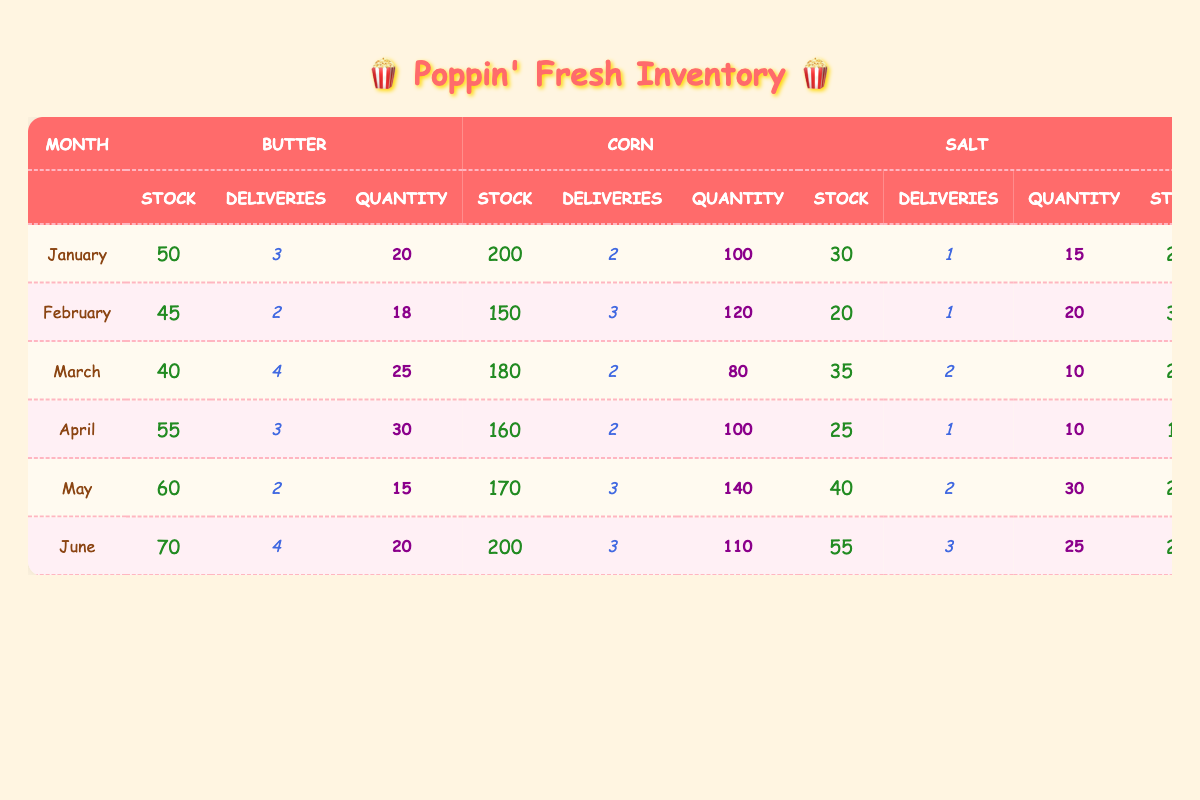What is the stock level of corn in June? Referring to the table, I locate the row for June and find the value listed under the corn "Stock" column. It shows a stock level of 200.
Answer: 200 How many supplier deliveries of salt were made in February? In the table, I check the row for February and find the "Deliveries" column under salt. The value is 1 delivery.
Answer: 1 What is the total stock level of butter from January to March? I sum the stock levels of butter for January (50), February (45), and March (40). The total is 50 + 45 + 40 = 135.
Answer: 135 Did the stock level of seasoning blend ever exceed 25 in these months? I review the stock levels of seasoning blend for all months listed in the table. The maximum mentioned is 30 in February. Therefore, it did exceed 25 during that month.
Answer: Yes What was the average delivery quantity of corn in the first three months? I sum the delivery quantities for corn in January (100), February (120), and March (80), which totals 300. Then I divide by the number of months (3). The average delivery quantity is 300/3 = 100.
Answer: 100 Which month had the highest stock level of salt? I analyze the stock levels of salt across the months and find the highest value is 55 in June.
Answer: June How many deliveries of seasoning blend were received in total from January to May? I add the delivery quantities for seasoning blend: January (10), February (15), March (12), April (15), and May (10). The total deliveries are 10 + 15 + 12 + 15 + 10 = 62.
Answer: 62 In which month did butter have the lowest stock level? I check the butter row across all months and find that the lowest stock level appears in March, where the stock level is 40.
Answer: March What is the difference in stock level of corn between June and January? The stock level of corn in June is 200 and in January, it is 200. The difference is 200 - 200 = 0.
Answer: 0 Did the stock level of butter ever drop below 45? Looking at the butter stock levels, I see that it dropped to 40 in March, confirming that it did drop below 45.
Answer: Yes 